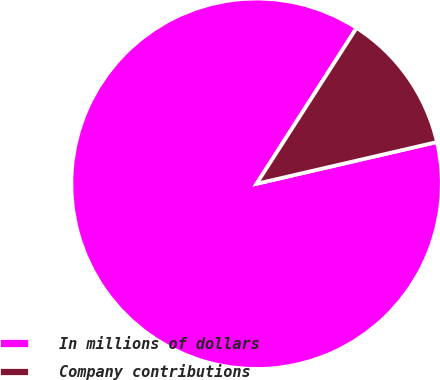<chart> <loc_0><loc_0><loc_500><loc_500><pie_chart><fcel>In millions of dollars<fcel>Company contributions<nl><fcel>87.7%<fcel>12.3%<nl></chart> 